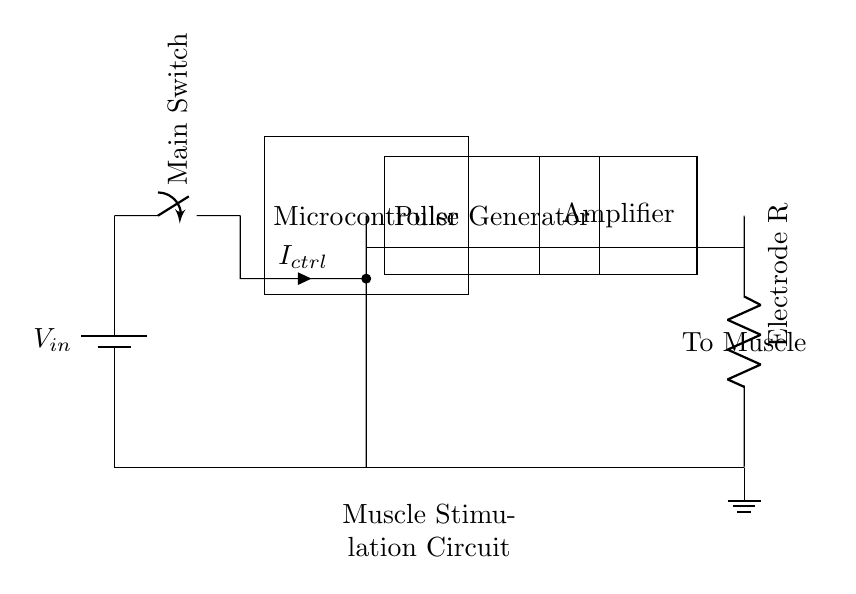What type of circuit is shown here? This circuit is a muscle stimulation circuit, specifically designed to help with post-training recovery. The components included are specifically tailored for delivering electrical pulses to stimulate muscles.
Answer: Muscle stimulation circuit What is the role of the microcontroller in this circuit? The microcontroller is responsible for controlling the operation of the pulse generator, which delivers the electrical stimuli to the muscles. It processes inputs and dictates the pulse characteristics based on the recovery needs.
Answer: Control How many outputs does the pulse generator provide? The pulse generator provides one output that connects to the amplifier, which then delivers the signal to the electrodes. Its function is to create the electrical pulses needed for muscle stimulation.
Answer: One What is the function of the amplifier in this circuit? The amplifier increases the power of the electrical signal generated by the pulse generator, ensuring that the signal is strong enough to effectively stimulate the muscles through the electrodes.
Answer: Increase signal What must be connected to complete the circuit? The circuit needs to be completed by connecting the electrodes to the muscle area, which allows the electrical pulses to reach the muscles for stimulation. This connection is essential for the circuit to function correctly.
Answer: Electrodes What is the power source for the circuit? The circuit uses a battery as its power source to provide the necessary voltage for operation. The battery is shown at the starting point of the diagram.
Answer: Battery What happens when the main switch is closed? When the main switch is closed, it allows current to flow from the battery to the microcontroller and the subsequent components, enabling the entire muscle stimulation circuit to operate.
Answer: Current flow 